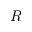Convert formula to latex. <formula><loc_0><loc_0><loc_500><loc_500>R</formula> 